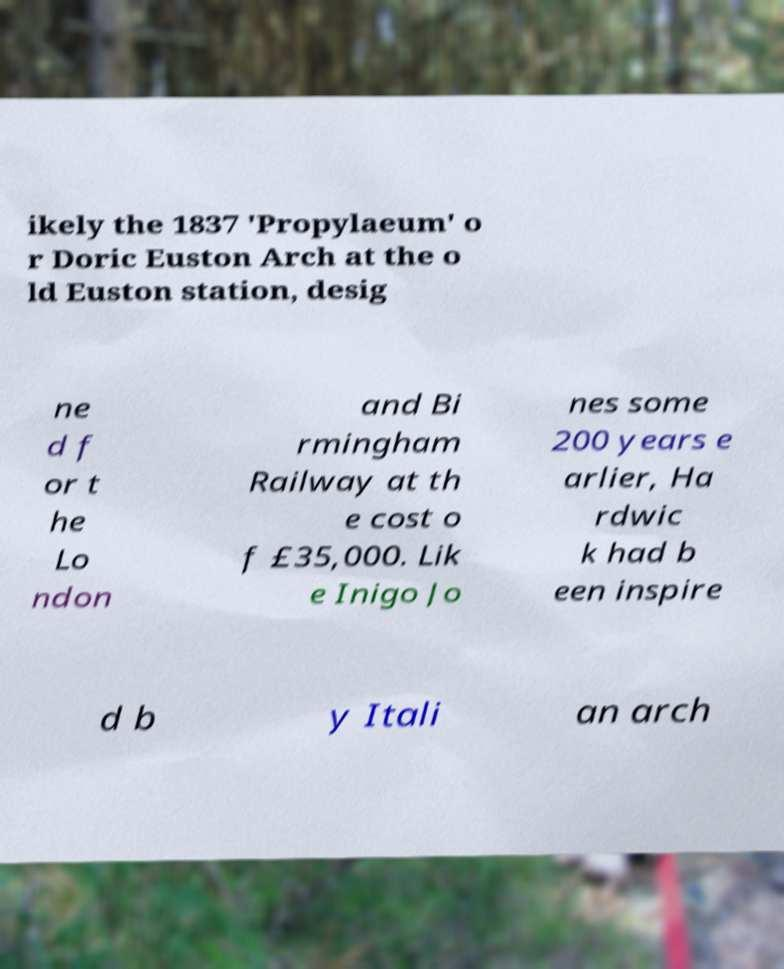Could you assist in decoding the text presented in this image and type it out clearly? ikely the 1837 'Propylaeum' o r Doric Euston Arch at the o ld Euston station, desig ne d f or t he Lo ndon and Bi rmingham Railway at th e cost o f £35,000. Lik e Inigo Jo nes some 200 years e arlier, Ha rdwic k had b een inspire d b y Itali an arch 